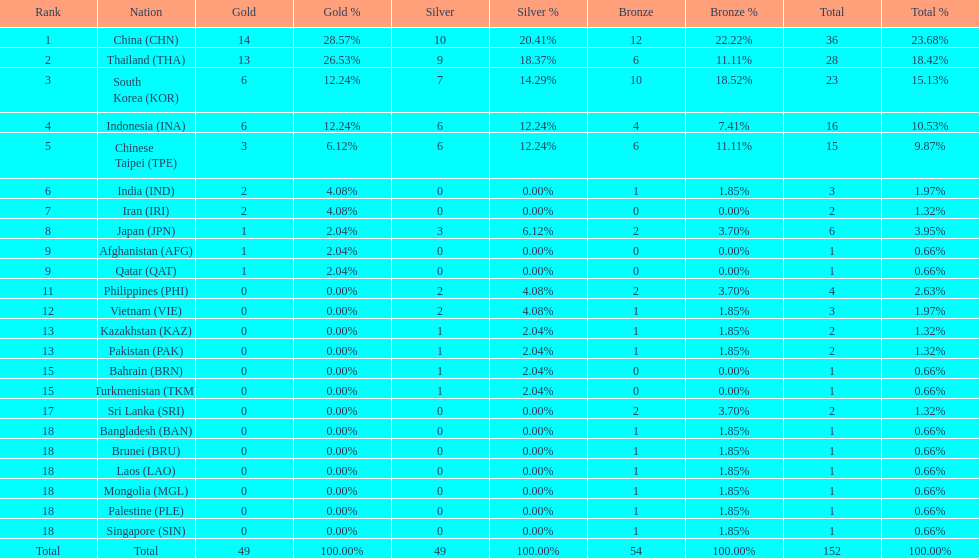In each of gold, silver, and bronze, how many nations were awarded a medal? 6. 